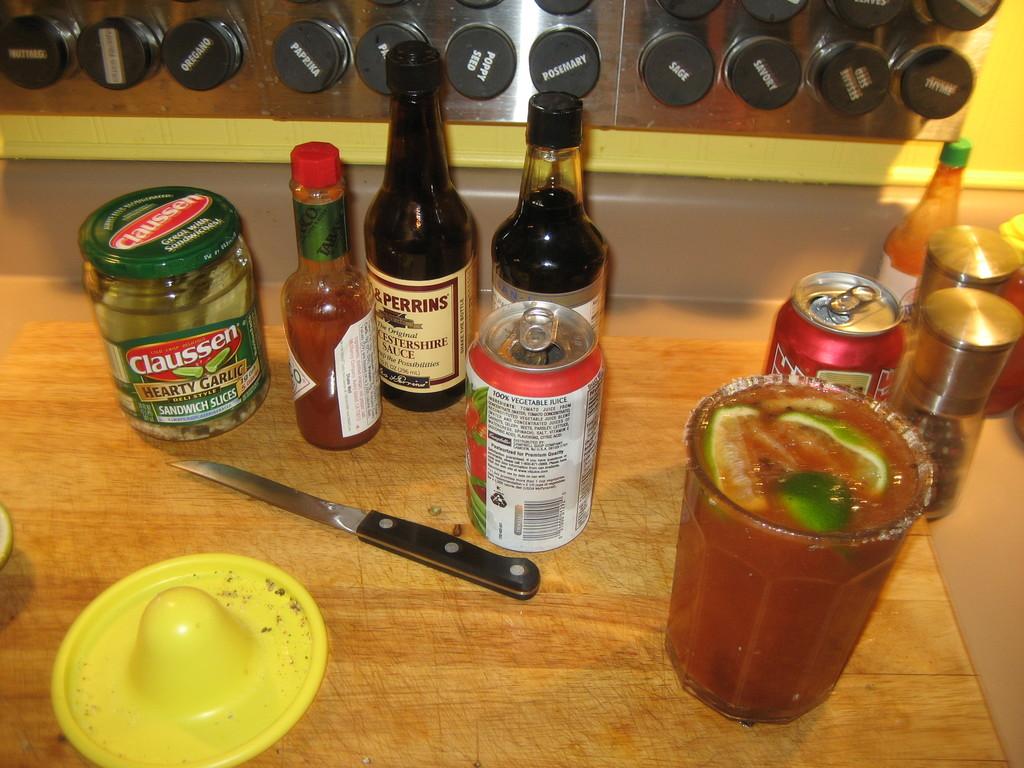What brand made the pickles?
Your answer should be compact. Claussen. What percent juice is the beverage in the can?
Make the answer very short. 100. 